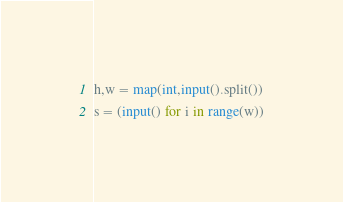<code> <loc_0><loc_0><loc_500><loc_500><_Python_>h,w = map(int,input().split())
s = (input() for i in range(w))
</code> 